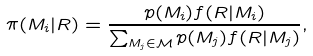<formula> <loc_0><loc_0><loc_500><loc_500>\pi ( M _ { i } | R ) = \frac { p ( M _ { i } ) f ( R | M _ { i } ) } { \sum _ { M _ { j } \in \mathcal { M } } p ( M _ { j } ) f ( R | M _ { j } ) } ,</formula> 